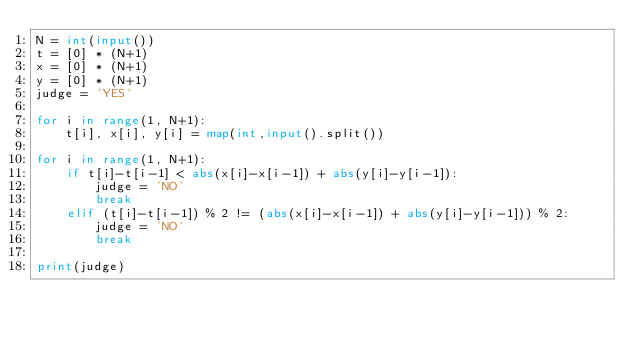Convert code to text. <code><loc_0><loc_0><loc_500><loc_500><_Python_>N = int(input())
t = [0] * (N+1)
x = [0] * (N+1)
y = [0] * (N+1)
judge = 'YES'

for i in range(1, N+1):
    t[i], x[i], y[i] = map(int,input().split())

for i in range(1, N+1):
    if t[i]-t[i-1] < abs(x[i]-x[i-1]) + abs(y[i]-y[i-1]):
        judge = 'NO'
        break
    elif (t[i]-t[i-1]) % 2 != (abs(x[i]-x[i-1]) + abs(y[i]-y[i-1])) % 2:
        judge = 'NO'
        break

print(judge)</code> 